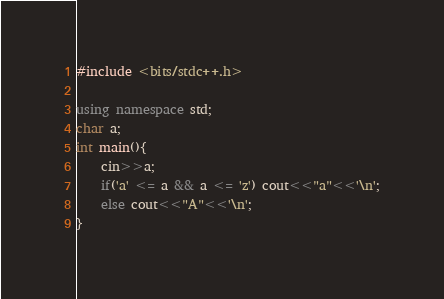Convert code to text. <code><loc_0><loc_0><loc_500><loc_500><_C++_>#include <bits/stdc++.h>

using namespace std;
char a;
int main(){
    cin>>a;
    if('a' <= a && a <= 'z') cout<<"a"<<'\n';
    else cout<<"A"<<'\n';
}
</code> 